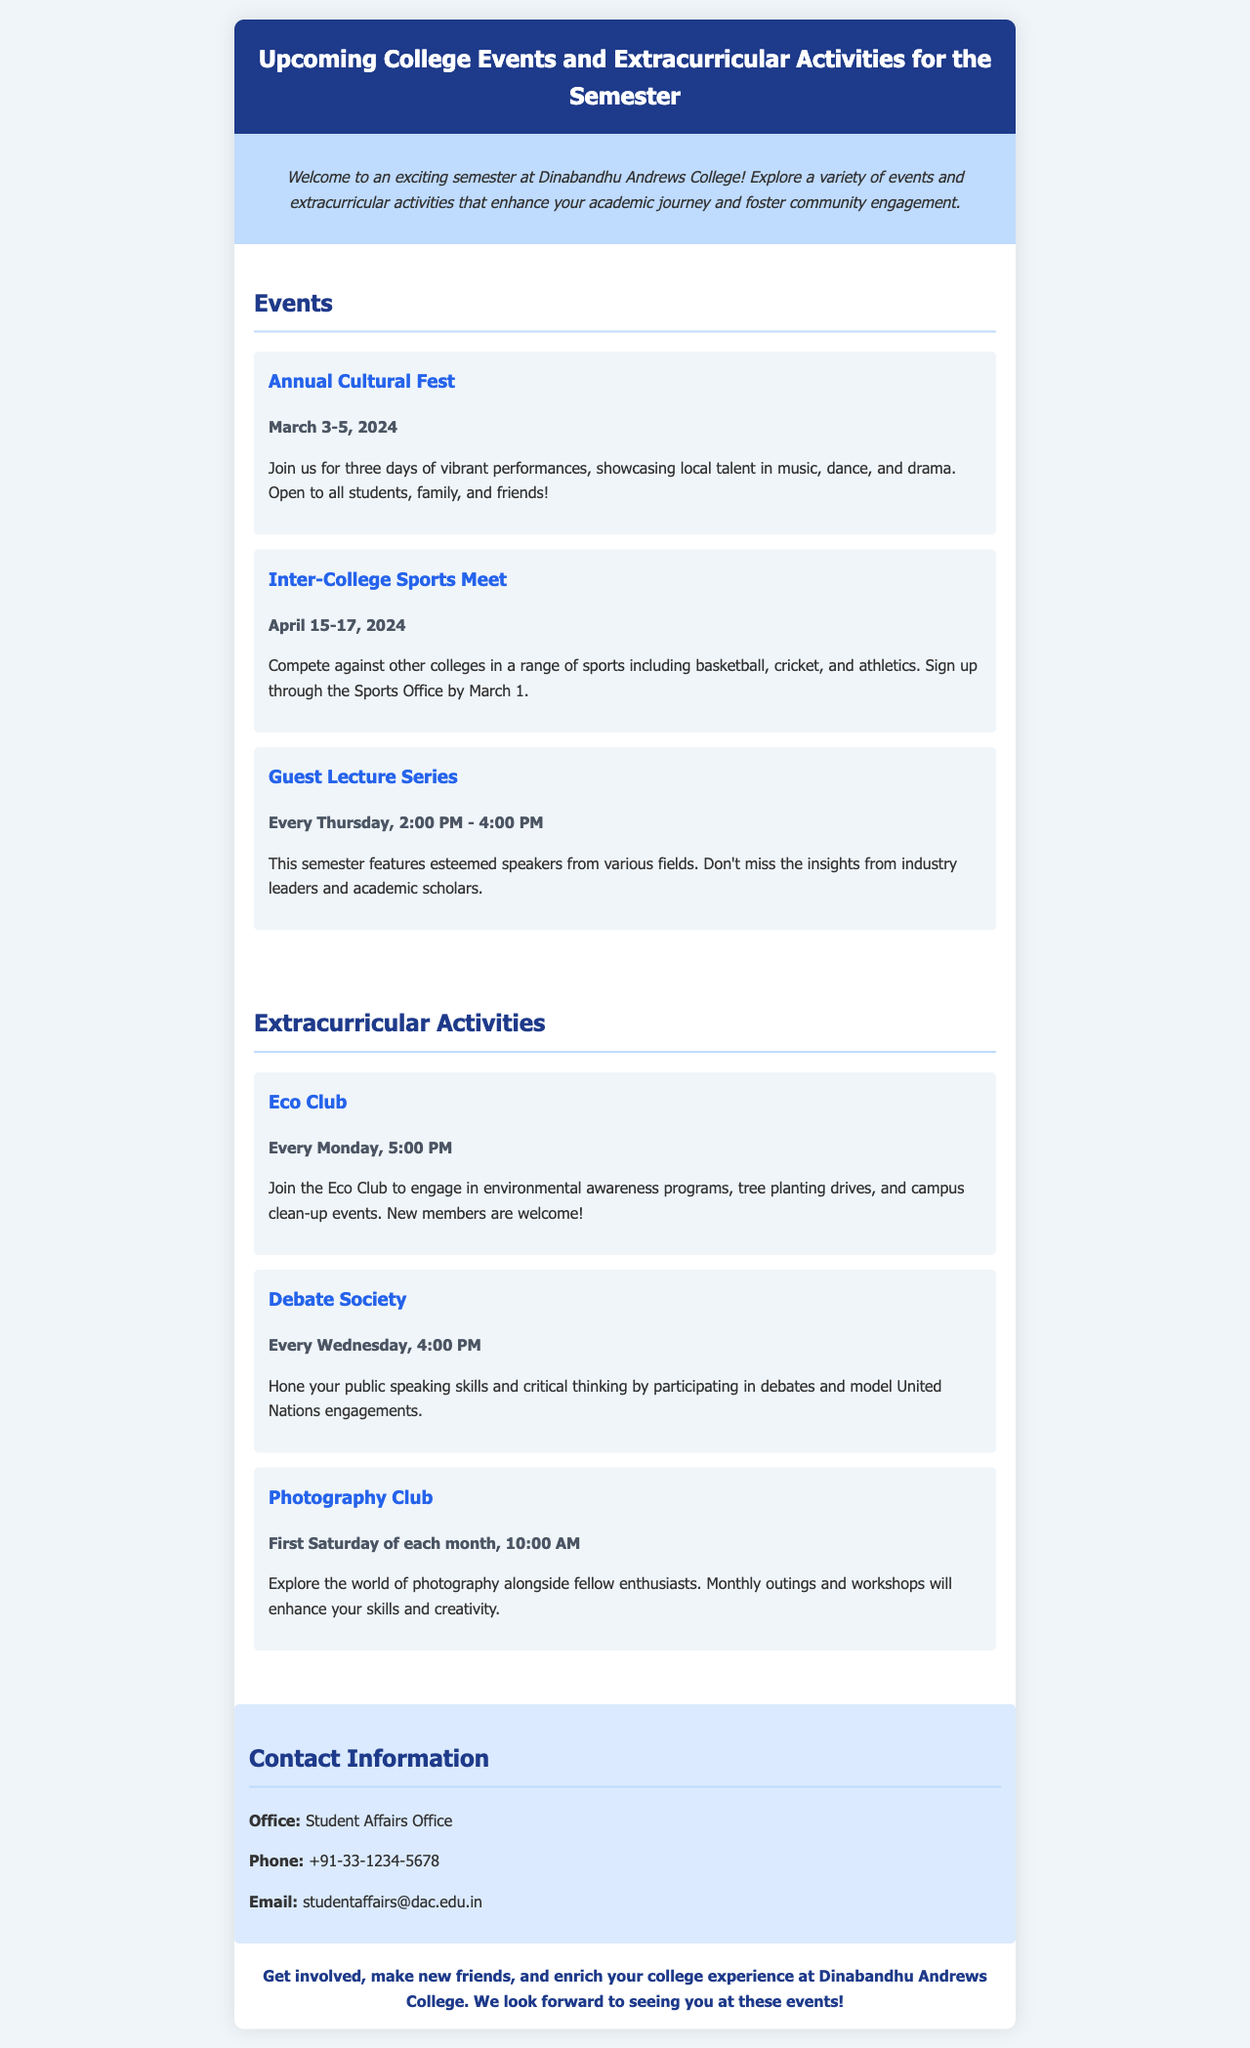What are the dates of the Annual Cultural Fest? The document states that the Annual Cultural Fest will take place from March 3 to March 5, 2024.
Answer: March 3-5, 2024 What time does the Guest Lecture Series start? According to the document, the Guest Lecture Series takes place every Thursday from 2:00 PM to 4:00 PM.
Answer: 2:00 PM When does the Eco Club meet? The document indicates that the Eco Club meets every Monday at 5:00 PM.
Answer: Every Monday, 5:00 PM What is the contact email for the Student Affairs Office? The email provided in the document for the Student Affairs Office is studentaffairs@dac.edu.in.
Answer: studentaffairs@dac.edu.in How often does the Photography Club hold meetings? The document mentions that the Photography Club meets on the first Saturday of each month.
Answer: First Saturday of each month What type of activities does the Debate Society focus on? The document specifies that the Debate Society is focused on public speaking skills and critical thinking through debates and model United Nations engagements.
Answer: Debates and model United Nations engagements What is the purpose of the Annual Cultural Fest? The document describes the Annual Cultural Fest as a vibrant celebration showcasing local talent in music, dance, and drama.
Answer: Showcasing local talent Which sport is mentioned as part of the Inter-College Sports Meet? The document lists basketball, cricket, and athletics as part of the sports that will be competed in.
Answer: Basketball, cricket, and athletics What role does the Student Affairs Office have? The document identifies the Student Affairs Office as the contact point for inquiries regarding events and extracurricular activities.
Answer: Contact point for inquiries 